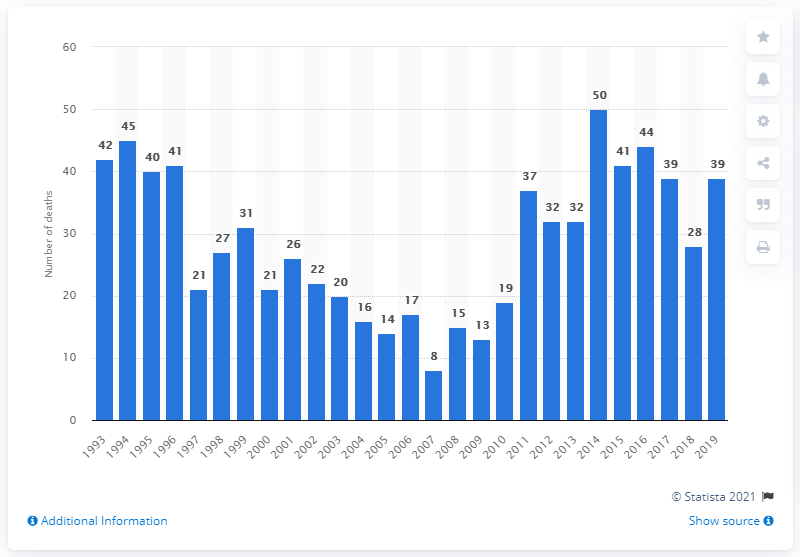Point out several critical features in this image. In 2014, there were 50 barbiturate-related drug deaths. 